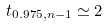<formula> <loc_0><loc_0><loc_500><loc_500>t _ { 0 . 9 7 5 , n - 1 } \simeq 2</formula> 